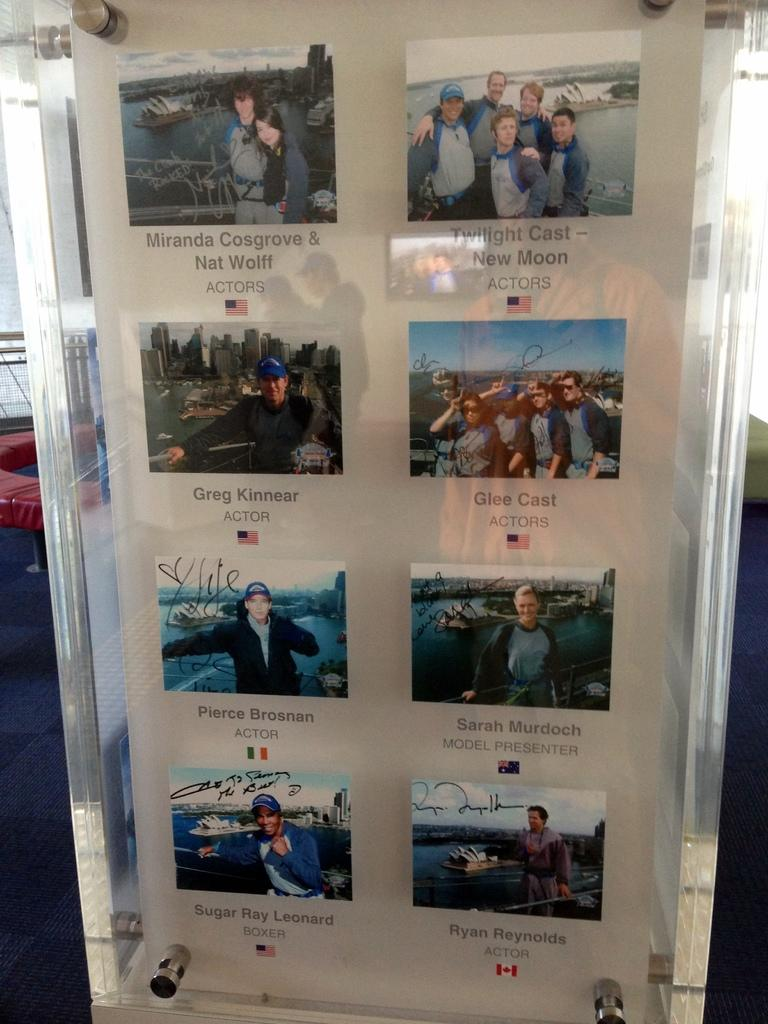<image>
Describe the image concisely. A case displays photographs of famous visitors, including Sugar Ray Leonard. 